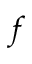<formula> <loc_0><loc_0><loc_500><loc_500>f</formula> 